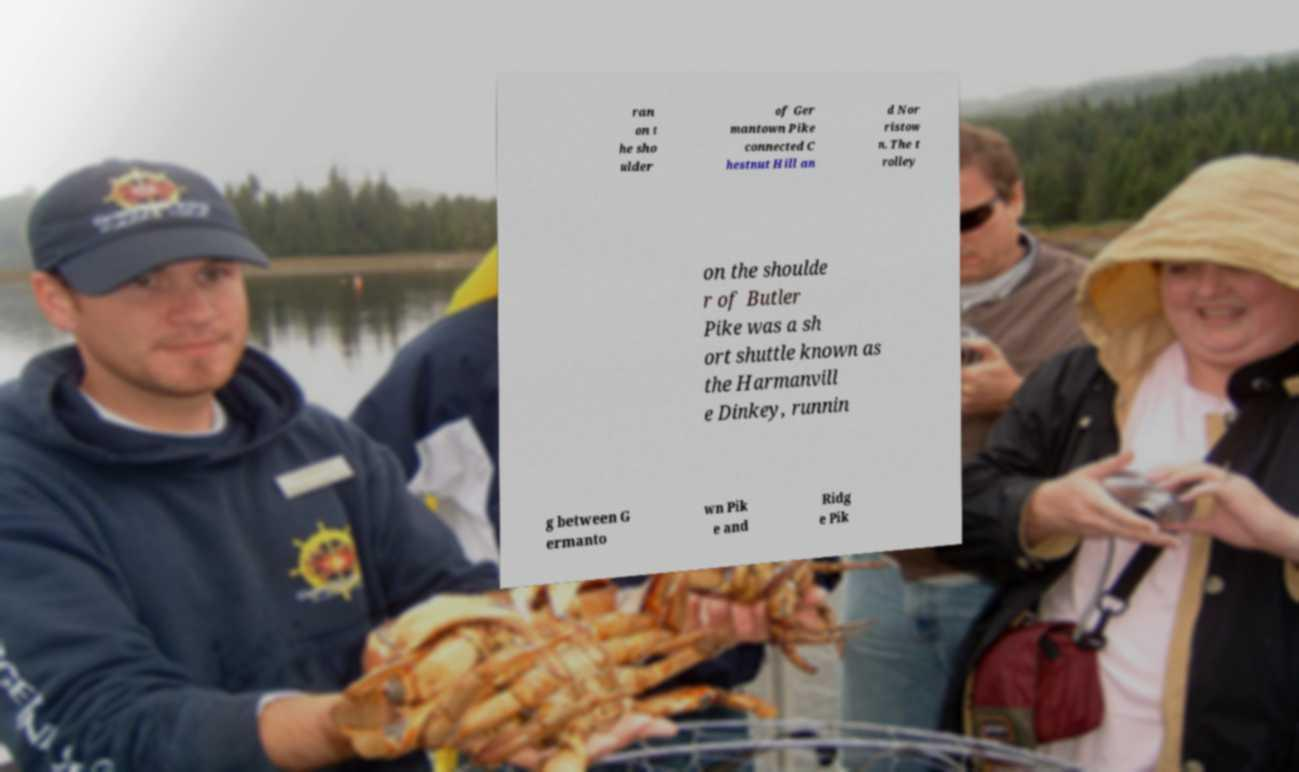For documentation purposes, I need the text within this image transcribed. Could you provide that? ran on t he sho ulder of Ger mantown Pike connected C hestnut Hill an d Nor ristow n. The t rolley on the shoulde r of Butler Pike was a sh ort shuttle known as the Harmanvill e Dinkey, runnin g between G ermanto wn Pik e and Ridg e Pik 